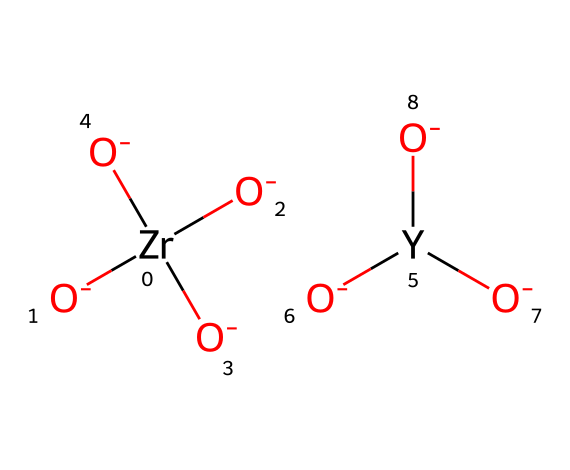What is the primary metal present in this structure? The chemical SMILES representation indicates the presence of Zr, which stands for zirconium, indicating it’s the primary metal in ytrria-stabilized zirconia.
Answer: zirconium How many oxygen atoms are bonded to zirconium in this structure? The structure shows four oxygen atoms directly attached to the zirconium atom, which is confirmed by the four 'O' in the SMILES notation.
Answer: four What is the purpose of adding yttrium to zirconia? Yttrium is added to stabilize the zirconia structure and enhance its ionic conductivity, particularly in solid oxide fuel cell applications.
Answer: stabilization What type of solid is yttria-stabilized zirconia? This compound is a ceramic, specifically a ceramic electrolyte used in applications such as solid oxide fuel cells.
Answer: ceramic How many coordination sites are occupied by zirconium in this arrangement? Zirconium has four oxygen atoms coordinating, which corresponds to the four 'O' atoms shown in the structure, indicating it has four coordination sites occupied.
Answer: four What is the oxidation state of zirconium in this compound? In the given structure, zirconium typically has a +4 oxidation state, as suggested by its bonding arrangement with four oxygen atoms.
Answer: +4 Does this compound exhibit ionic or covalent bonding? The interactions between zirconium and oxygen in this structure indicate ionic bonding characteristics, particularly due to the presence of charged oxygen.
Answer: ionic 